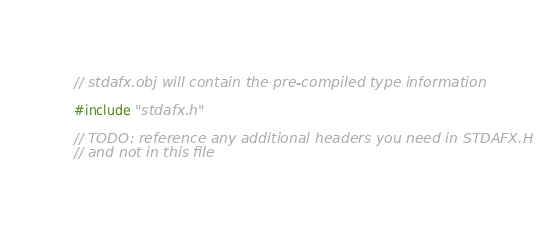<code> <loc_0><loc_0><loc_500><loc_500><_C++_>// stdafx.obj will contain the pre-compiled type information

#include "stdafx.h"

// TODO: reference any additional headers you need in STDAFX.H
// and not in this file
</code> 